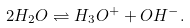Convert formula to latex. <formula><loc_0><loc_0><loc_500><loc_500>2 H _ { 2 } O \rightleftharpoons H _ { 3 } O ^ { + } + O H ^ { - } .</formula> 